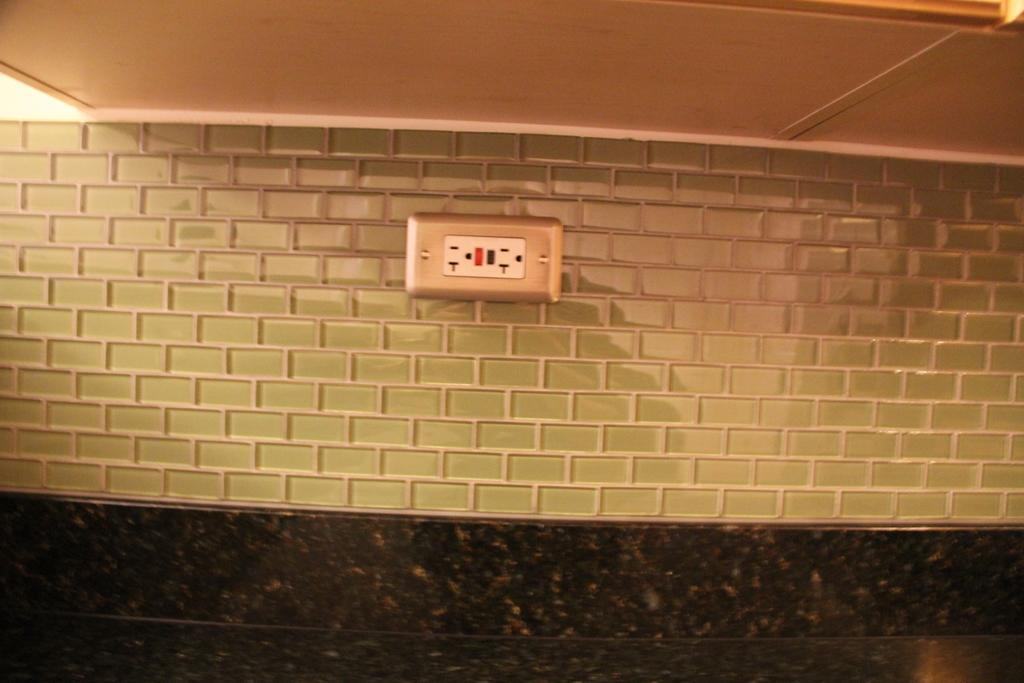Describe this image in one or two sentences. In this image I can see a socket on the wall. 